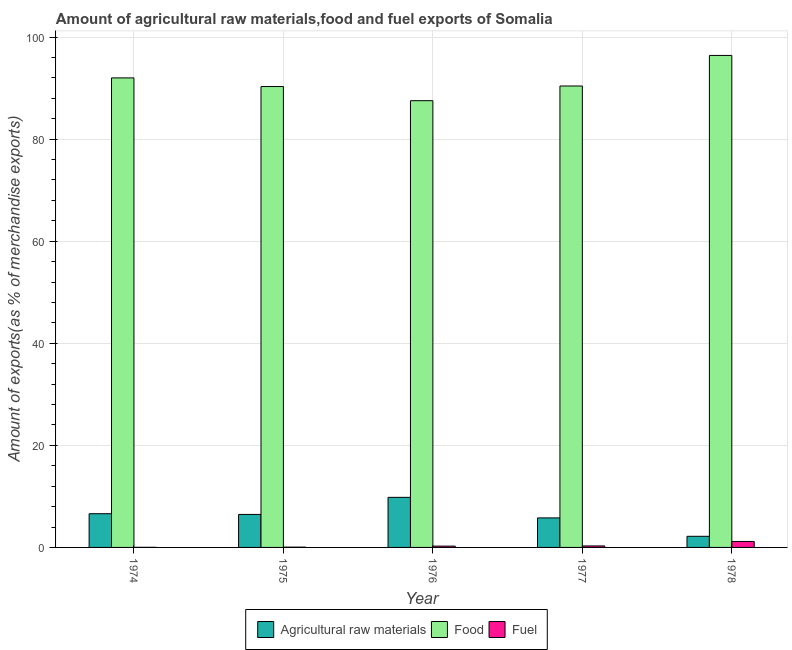How many groups of bars are there?
Keep it short and to the point. 5. Are the number of bars per tick equal to the number of legend labels?
Ensure brevity in your answer.  Yes. How many bars are there on the 3rd tick from the left?
Give a very brief answer. 3. What is the label of the 1st group of bars from the left?
Keep it short and to the point. 1974. In how many cases, is the number of bars for a given year not equal to the number of legend labels?
Provide a short and direct response. 0. What is the percentage of food exports in 1974?
Provide a short and direct response. 92. Across all years, what is the maximum percentage of raw materials exports?
Offer a very short reply. 9.81. Across all years, what is the minimum percentage of fuel exports?
Make the answer very short. 0.02. In which year was the percentage of raw materials exports maximum?
Give a very brief answer. 1976. In which year was the percentage of food exports minimum?
Ensure brevity in your answer.  1976. What is the total percentage of food exports in the graph?
Offer a terse response. 456.64. What is the difference between the percentage of food exports in 1974 and that in 1976?
Your answer should be very brief. 4.47. What is the difference between the percentage of food exports in 1975 and the percentage of raw materials exports in 1978?
Offer a terse response. -6.09. What is the average percentage of raw materials exports per year?
Offer a very short reply. 6.17. In how many years, is the percentage of food exports greater than 92 %?
Keep it short and to the point. 1. What is the ratio of the percentage of raw materials exports in 1976 to that in 1977?
Provide a succinct answer. 1.7. Is the percentage of food exports in 1976 less than that in 1978?
Give a very brief answer. Yes. What is the difference between the highest and the second highest percentage of fuel exports?
Provide a succinct answer. 0.87. What is the difference between the highest and the lowest percentage of food exports?
Offer a terse response. 8.87. Is the sum of the percentage of food exports in 1974 and 1975 greater than the maximum percentage of fuel exports across all years?
Provide a short and direct response. Yes. What does the 3rd bar from the left in 1976 represents?
Provide a succinct answer. Fuel. What does the 2nd bar from the right in 1978 represents?
Keep it short and to the point. Food. Is it the case that in every year, the sum of the percentage of raw materials exports and percentage of food exports is greater than the percentage of fuel exports?
Your answer should be very brief. Yes. How many bars are there?
Your answer should be compact. 15. Does the graph contain any zero values?
Provide a succinct answer. No. Does the graph contain grids?
Offer a terse response. Yes. Where does the legend appear in the graph?
Provide a short and direct response. Bottom center. How many legend labels are there?
Offer a very short reply. 3. What is the title of the graph?
Offer a very short reply. Amount of agricultural raw materials,food and fuel exports of Somalia. What is the label or title of the X-axis?
Your answer should be compact. Year. What is the label or title of the Y-axis?
Offer a terse response. Amount of exports(as % of merchandise exports). What is the Amount of exports(as % of merchandise exports) in Agricultural raw materials in 1974?
Your response must be concise. 6.61. What is the Amount of exports(as % of merchandise exports) of Food in 1974?
Provide a succinct answer. 92. What is the Amount of exports(as % of merchandise exports) in Fuel in 1974?
Your answer should be very brief. 0.02. What is the Amount of exports(as % of merchandise exports) in Agricultural raw materials in 1975?
Provide a short and direct response. 6.47. What is the Amount of exports(as % of merchandise exports) in Food in 1975?
Your answer should be compact. 90.3. What is the Amount of exports(as % of merchandise exports) in Fuel in 1975?
Provide a short and direct response. 0.06. What is the Amount of exports(as % of merchandise exports) in Agricultural raw materials in 1976?
Offer a very short reply. 9.81. What is the Amount of exports(as % of merchandise exports) of Food in 1976?
Give a very brief answer. 87.53. What is the Amount of exports(as % of merchandise exports) in Fuel in 1976?
Your answer should be compact. 0.26. What is the Amount of exports(as % of merchandise exports) of Agricultural raw materials in 1977?
Keep it short and to the point. 5.78. What is the Amount of exports(as % of merchandise exports) of Food in 1977?
Offer a terse response. 90.41. What is the Amount of exports(as % of merchandise exports) in Fuel in 1977?
Offer a terse response. 0.29. What is the Amount of exports(as % of merchandise exports) in Agricultural raw materials in 1978?
Provide a succinct answer. 2.18. What is the Amount of exports(as % of merchandise exports) in Food in 1978?
Your response must be concise. 96.4. What is the Amount of exports(as % of merchandise exports) in Fuel in 1978?
Provide a short and direct response. 1.17. Across all years, what is the maximum Amount of exports(as % of merchandise exports) of Agricultural raw materials?
Make the answer very short. 9.81. Across all years, what is the maximum Amount of exports(as % of merchandise exports) of Food?
Offer a very short reply. 96.4. Across all years, what is the maximum Amount of exports(as % of merchandise exports) of Fuel?
Offer a terse response. 1.17. Across all years, what is the minimum Amount of exports(as % of merchandise exports) of Agricultural raw materials?
Give a very brief answer. 2.18. Across all years, what is the minimum Amount of exports(as % of merchandise exports) in Food?
Provide a succinct answer. 87.53. Across all years, what is the minimum Amount of exports(as % of merchandise exports) in Fuel?
Provide a succinct answer. 0.02. What is the total Amount of exports(as % of merchandise exports) in Agricultural raw materials in the graph?
Make the answer very short. 30.85. What is the total Amount of exports(as % of merchandise exports) of Food in the graph?
Make the answer very short. 456.64. What is the total Amount of exports(as % of merchandise exports) in Fuel in the graph?
Give a very brief answer. 1.79. What is the difference between the Amount of exports(as % of merchandise exports) of Agricultural raw materials in 1974 and that in 1975?
Your response must be concise. 0.14. What is the difference between the Amount of exports(as % of merchandise exports) in Food in 1974 and that in 1975?
Provide a short and direct response. 1.69. What is the difference between the Amount of exports(as % of merchandise exports) of Fuel in 1974 and that in 1975?
Your answer should be compact. -0.04. What is the difference between the Amount of exports(as % of merchandise exports) of Agricultural raw materials in 1974 and that in 1976?
Your answer should be very brief. -3.21. What is the difference between the Amount of exports(as % of merchandise exports) in Food in 1974 and that in 1976?
Your answer should be compact. 4.47. What is the difference between the Amount of exports(as % of merchandise exports) in Fuel in 1974 and that in 1976?
Offer a terse response. -0.24. What is the difference between the Amount of exports(as % of merchandise exports) of Agricultural raw materials in 1974 and that in 1977?
Provide a short and direct response. 0.82. What is the difference between the Amount of exports(as % of merchandise exports) of Food in 1974 and that in 1977?
Provide a succinct answer. 1.59. What is the difference between the Amount of exports(as % of merchandise exports) in Fuel in 1974 and that in 1977?
Your answer should be compact. -0.28. What is the difference between the Amount of exports(as % of merchandise exports) of Agricultural raw materials in 1974 and that in 1978?
Keep it short and to the point. 4.43. What is the difference between the Amount of exports(as % of merchandise exports) in Food in 1974 and that in 1978?
Your answer should be very brief. -4.4. What is the difference between the Amount of exports(as % of merchandise exports) of Fuel in 1974 and that in 1978?
Your response must be concise. -1.15. What is the difference between the Amount of exports(as % of merchandise exports) of Agricultural raw materials in 1975 and that in 1976?
Give a very brief answer. -3.35. What is the difference between the Amount of exports(as % of merchandise exports) of Food in 1975 and that in 1976?
Your answer should be compact. 2.77. What is the difference between the Amount of exports(as % of merchandise exports) of Fuel in 1975 and that in 1976?
Your response must be concise. -0.2. What is the difference between the Amount of exports(as % of merchandise exports) in Agricultural raw materials in 1975 and that in 1977?
Provide a succinct answer. 0.68. What is the difference between the Amount of exports(as % of merchandise exports) of Food in 1975 and that in 1977?
Ensure brevity in your answer.  -0.1. What is the difference between the Amount of exports(as % of merchandise exports) in Fuel in 1975 and that in 1977?
Provide a succinct answer. -0.24. What is the difference between the Amount of exports(as % of merchandise exports) in Agricultural raw materials in 1975 and that in 1978?
Your answer should be compact. 4.29. What is the difference between the Amount of exports(as % of merchandise exports) in Food in 1975 and that in 1978?
Provide a short and direct response. -6.09. What is the difference between the Amount of exports(as % of merchandise exports) of Fuel in 1975 and that in 1978?
Make the answer very short. -1.11. What is the difference between the Amount of exports(as % of merchandise exports) in Agricultural raw materials in 1976 and that in 1977?
Offer a very short reply. 4.03. What is the difference between the Amount of exports(as % of merchandise exports) in Food in 1976 and that in 1977?
Offer a terse response. -2.88. What is the difference between the Amount of exports(as % of merchandise exports) in Fuel in 1976 and that in 1977?
Give a very brief answer. -0.04. What is the difference between the Amount of exports(as % of merchandise exports) in Agricultural raw materials in 1976 and that in 1978?
Your response must be concise. 7.63. What is the difference between the Amount of exports(as % of merchandise exports) of Food in 1976 and that in 1978?
Your answer should be very brief. -8.87. What is the difference between the Amount of exports(as % of merchandise exports) of Fuel in 1976 and that in 1978?
Ensure brevity in your answer.  -0.91. What is the difference between the Amount of exports(as % of merchandise exports) of Agricultural raw materials in 1977 and that in 1978?
Offer a terse response. 3.6. What is the difference between the Amount of exports(as % of merchandise exports) of Food in 1977 and that in 1978?
Ensure brevity in your answer.  -5.99. What is the difference between the Amount of exports(as % of merchandise exports) in Fuel in 1977 and that in 1978?
Your answer should be very brief. -0.87. What is the difference between the Amount of exports(as % of merchandise exports) in Agricultural raw materials in 1974 and the Amount of exports(as % of merchandise exports) in Food in 1975?
Offer a terse response. -83.7. What is the difference between the Amount of exports(as % of merchandise exports) of Agricultural raw materials in 1974 and the Amount of exports(as % of merchandise exports) of Fuel in 1975?
Make the answer very short. 6.55. What is the difference between the Amount of exports(as % of merchandise exports) in Food in 1974 and the Amount of exports(as % of merchandise exports) in Fuel in 1975?
Provide a short and direct response. 91.94. What is the difference between the Amount of exports(as % of merchandise exports) of Agricultural raw materials in 1974 and the Amount of exports(as % of merchandise exports) of Food in 1976?
Your answer should be compact. -80.92. What is the difference between the Amount of exports(as % of merchandise exports) in Agricultural raw materials in 1974 and the Amount of exports(as % of merchandise exports) in Fuel in 1976?
Your response must be concise. 6.35. What is the difference between the Amount of exports(as % of merchandise exports) of Food in 1974 and the Amount of exports(as % of merchandise exports) of Fuel in 1976?
Your response must be concise. 91.74. What is the difference between the Amount of exports(as % of merchandise exports) of Agricultural raw materials in 1974 and the Amount of exports(as % of merchandise exports) of Food in 1977?
Keep it short and to the point. -83.8. What is the difference between the Amount of exports(as % of merchandise exports) of Agricultural raw materials in 1974 and the Amount of exports(as % of merchandise exports) of Fuel in 1977?
Make the answer very short. 6.31. What is the difference between the Amount of exports(as % of merchandise exports) of Food in 1974 and the Amount of exports(as % of merchandise exports) of Fuel in 1977?
Provide a short and direct response. 91.7. What is the difference between the Amount of exports(as % of merchandise exports) of Agricultural raw materials in 1974 and the Amount of exports(as % of merchandise exports) of Food in 1978?
Provide a short and direct response. -89.79. What is the difference between the Amount of exports(as % of merchandise exports) in Agricultural raw materials in 1974 and the Amount of exports(as % of merchandise exports) in Fuel in 1978?
Make the answer very short. 5.44. What is the difference between the Amount of exports(as % of merchandise exports) in Food in 1974 and the Amount of exports(as % of merchandise exports) in Fuel in 1978?
Your answer should be very brief. 90.83. What is the difference between the Amount of exports(as % of merchandise exports) of Agricultural raw materials in 1975 and the Amount of exports(as % of merchandise exports) of Food in 1976?
Make the answer very short. -81.06. What is the difference between the Amount of exports(as % of merchandise exports) of Agricultural raw materials in 1975 and the Amount of exports(as % of merchandise exports) of Fuel in 1976?
Offer a terse response. 6.21. What is the difference between the Amount of exports(as % of merchandise exports) of Food in 1975 and the Amount of exports(as % of merchandise exports) of Fuel in 1976?
Offer a terse response. 90.05. What is the difference between the Amount of exports(as % of merchandise exports) of Agricultural raw materials in 1975 and the Amount of exports(as % of merchandise exports) of Food in 1977?
Keep it short and to the point. -83.94. What is the difference between the Amount of exports(as % of merchandise exports) in Agricultural raw materials in 1975 and the Amount of exports(as % of merchandise exports) in Fuel in 1977?
Provide a short and direct response. 6.17. What is the difference between the Amount of exports(as % of merchandise exports) of Food in 1975 and the Amount of exports(as % of merchandise exports) of Fuel in 1977?
Offer a terse response. 90.01. What is the difference between the Amount of exports(as % of merchandise exports) in Agricultural raw materials in 1975 and the Amount of exports(as % of merchandise exports) in Food in 1978?
Offer a terse response. -89.93. What is the difference between the Amount of exports(as % of merchandise exports) in Agricultural raw materials in 1975 and the Amount of exports(as % of merchandise exports) in Fuel in 1978?
Your answer should be very brief. 5.3. What is the difference between the Amount of exports(as % of merchandise exports) in Food in 1975 and the Amount of exports(as % of merchandise exports) in Fuel in 1978?
Your answer should be compact. 89.14. What is the difference between the Amount of exports(as % of merchandise exports) of Agricultural raw materials in 1976 and the Amount of exports(as % of merchandise exports) of Food in 1977?
Keep it short and to the point. -80.6. What is the difference between the Amount of exports(as % of merchandise exports) of Agricultural raw materials in 1976 and the Amount of exports(as % of merchandise exports) of Fuel in 1977?
Your answer should be compact. 9.52. What is the difference between the Amount of exports(as % of merchandise exports) of Food in 1976 and the Amount of exports(as % of merchandise exports) of Fuel in 1977?
Your response must be concise. 87.24. What is the difference between the Amount of exports(as % of merchandise exports) of Agricultural raw materials in 1976 and the Amount of exports(as % of merchandise exports) of Food in 1978?
Make the answer very short. -86.59. What is the difference between the Amount of exports(as % of merchandise exports) in Agricultural raw materials in 1976 and the Amount of exports(as % of merchandise exports) in Fuel in 1978?
Keep it short and to the point. 8.64. What is the difference between the Amount of exports(as % of merchandise exports) in Food in 1976 and the Amount of exports(as % of merchandise exports) in Fuel in 1978?
Ensure brevity in your answer.  86.36. What is the difference between the Amount of exports(as % of merchandise exports) of Agricultural raw materials in 1977 and the Amount of exports(as % of merchandise exports) of Food in 1978?
Make the answer very short. -90.61. What is the difference between the Amount of exports(as % of merchandise exports) of Agricultural raw materials in 1977 and the Amount of exports(as % of merchandise exports) of Fuel in 1978?
Ensure brevity in your answer.  4.62. What is the difference between the Amount of exports(as % of merchandise exports) in Food in 1977 and the Amount of exports(as % of merchandise exports) in Fuel in 1978?
Keep it short and to the point. 89.24. What is the average Amount of exports(as % of merchandise exports) of Agricultural raw materials per year?
Make the answer very short. 6.17. What is the average Amount of exports(as % of merchandise exports) in Food per year?
Provide a succinct answer. 91.33. What is the average Amount of exports(as % of merchandise exports) in Fuel per year?
Provide a succinct answer. 0.36. In the year 1974, what is the difference between the Amount of exports(as % of merchandise exports) of Agricultural raw materials and Amount of exports(as % of merchandise exports) of Food?
Offer a terse response. -85.39. In the year 1974, what is the difference between the Amount of exports(as % of merchandise exports) in Agricultural raw materials and Amount of exports(as % of merchandise exports) in Fuel?
Offer a very short reply. 6.59. In the year 1974, what is the difference between the Amount of exports(as % of merchandise exports) in Food and Amount of exports(as % of merchandise exports) in Fuel?
Make the answer very short. 91.98. In the year 1975, what is the difference between the Amount of exports(as % of merchandise exports) of Agricultural raw materials and Amount of exports(as % of merchandise exports) of Food?
Keep it short and to the point. -83.84. In the year 1975, what is the difference between the Amount of exports(as % of merchandise exports) of Agricultural raw materials and Amount of exports(as % of merchandise exports) of Fuel?
Give a very brief answer. 6.41. In the year 1975, what is the difference between the Amount of exports(as % of merchandise exports) in Food and Amount of exports(as % of merchandise exports) in Fuel?
Your response must be concise. 90.24. In the year 1976, what is the difference between the Amount of exports(as % of merchandise exports) in Agricultural raw materials and Amount of exports(as % of merchandise exports) in Food?
Ensure brevity in your answer.  -77.72. In the year 1976, what is the difference between the Amount of exports(as % of merchandise exports) of Agricultural raw materials and Amount of exports(as % of merchandise exports) of Fuel?
Keep it short and to the point. 9.56. In the year 1976, what is the difference between the Amount of exports(as % of merchandise exports) in Food and Amount of exports(as % of merchandise exports) in Fuel?
Your answer should be very brief. 87.27. In the year 1977, what is the difference between the Amount of exports(as % of merchandise exports) in Agricultural raw materials and Amount of exports(as % of merchandise exports) in Food?
Provide a short and direct response. -84.62. In the year 1977, what is the difference between the Amount of exports(as % of merchandise exports) in Agricultural raw materials and Amount of exports(as % of merchandise exports) in Fuel?
Your response must be concise. 5.49. In the year 1977, what is the difference between the Amount of exports(as % of merchandise exports) of Food and Amount of exports(as % of merchandise exports) of Fuel?
Provide a succinct answer. 90.11. In the year 1978, what is the difference between the Amount of exports(as % of merchandise exports) in Agricultural raw materials and Amount of exports(as % of merchandise exports) in Food?
Offer a very short reply. -94.22. In the year 1978, what is the difference between the Amount of exports(as % of merchandise exports) in Agricultural raw materials and Amount of exports(as % of merchandise exports) in Fuel?
Give a very brief answer. 1.01. In the year 1978, what is the difference between the Amount of exports(as % of merchandise exports) in Food and Amount of exports(as % of merchandise exports) in Fuel?
Offer a very short reply. 95.23. What is the ratio of the Amount of exports(as % of merchandise exports) of Agricultural raw materials in 1974 to that in 1975?
Provide a succinct answer. 1.02. What is the ratio of the Amount of exports(as % of merchandise exports) of Food in 1974 to that in 1975?
Make the answer very short. 1.02. What is the ratio of the Amount of exports(as % of merchandise exports) of Fuel in 1974 to that in 1975?
Offer a very short reply. 0.31. What is the ratio of the Amount of exports(as % of merchandise exports) in Agricultural raw materials in 1974 to that in 1976?
Ensure brevity in your answer.  0.67. What is the ratio of the Amount of exports(as % of merchandise exports) of Food in 1974 to that in 1976?
Give a very brief answer. 1.05. What is the ratio of the Amount of exports(as % of merchandise exports) in Fuel in 1974 to that in 1976?
Give a very brief answer. 0.07. What is the ratio of the Amount of exports(as % of merchandise exports) of Agricultural raw materials in 1974 to that in 1977?
Provide a short and direct response. 1.14. What is the ratio of the Amount of exports(as % of merchandise exports) in Food in 1974 to that in 1977?
Offer a very short reply. 1.02. What is the ratio of the Amount of exports(as % of merchandise exports) of Fuel in 1974 to that in 1977?
Provide a short and direct response. 0.06. What is the ratio of the Amount of exports(as % of merchandise exports) in Agricultural raw materials in 1974 to that in 1978?
Provide a short and direct response. 3.03. What is the ratio of the Amount of exports(as % of merchandise exports) of Food in 1974 to that in 1978?
Offer a very short reply. 0.95. What is the ratio of the Amount of exports(as % of merchandise exports) in Fuel in 1974 to that in 1978?
Make the answer very short. 0.02. What is the ratio of the Amount of exports(as % of merchandise exports) in Agricultural raw materials in 1975 to that in 1976?
Give a very brief answer. 0.66. What is the ratio of the Amount of exports(as % of merchandise exports) in Food in 1975 to that in 1976?
Make the answer very short. 1.03. What is the ratio of the Amount of exports(as % of merchandise exports) of Fuel in 1975 to that in 1976?
Offer a very short reply. 0.23. What is the ratio of the Amount of exports(as % of merchandise exports) in Agricultural raw materials in 1975 to that in 1977?
Provide a succinct answer. 1.12. What is the ratio of the Amount of exports(as % of merchandise exports) of Food in 1975 to that in 1977?
Provide a short and direct response. 1. What is the ratio of the Amount of exports(as % of merchandise exports) in Fuel in 1975 to that in 1977?
Your answer should be compact. 0.2. What is the ratio of the Amount of exports(as % of merchandise exports) of Agricultural raw materials in 1975 to that in 1978?
Your answer should be compact. 2.97. What is the ratio of the Amount of exports(as % of merchandise exports) of Food in 1975 to that in 1978?
Your response must be concise. 0.94. What is the ratio of the Amount of exports(as % of merchandise exports) of Fuel in 1975 to that in 1978?
Provide a succinct answer. 0.05. What is the ratio of the Amount of exports(as % of merchandise exports) of Agricultural raw materials in 1976 to that in 1977?
Offer a very short reply. 1.7. What is the ratio of the Amount of exports(as % of merchandise exports) in Food in 1976 to that in 1977?
Provide a succinct answer. 0.97. What is the ratio of the Amount of exports(as % of merchandise exports) in Fuel in 1976 to that in 1977?
Make the answer very short. 0.87. What is the ratio of the Amount of exports(as % of merchandise exports) in Agricultural raw materials in 1976 to that in 1978?
Give a very brief answer. 4.5. What is the ratio of the Amount of exports(as % of merchandise exports) of Food in 1976 to that in 1978?
Give a very brief answer. 0.91. What is the ratio of the Amount of exports(as % of merchandise exports) of Fuel in 1976 to that in 1978?
Offer a very short reply. 0.22. What is the ratio of the Amount of exports(as % of merchandise exports) of Agricultural raw materials in 1977 to that in 1978?
Provide a short and direct response. 2.65. What is the ratio of the Amount of exports(as % of merchandise exports) in Food in 1977 to that in 1978?
Your answer should be compact. 0.94. What is the ratio of the Amount of exports(as % of merchandise exports) in Fuel in 1977 to that in 1978?
Provide a succinct answer. 0.25. What is the difference between the highest and the second highest Amount of exports(as % of merchandise exports) of Agricultural raw materials?
Offer a terse response. 3.21. What is the difference between the highest and the second highest Amount of exports(as % of merchandise exports) of Food?
Give a very brief answer. 4.4. What is the difference between the highest and the second highest Amount of exports(as % of merchandise exports) of Fuel?
Your response must be concise. 0.87. What is the difference between the highest and the lowest Amount of exports(as % of merchandise exports) of Agricultural raw materials?
Provide a succinct answer. 7.63. What is the difference between the highest and the lowest Amount of exports(as % of merchandise exports) of Food?
Your answer should be very brief. 8.87. What is the difference between the highest and the lowest Amount of exports(as % of merchandise exports) in Fuel?
Offer a terse response. 1.15. 